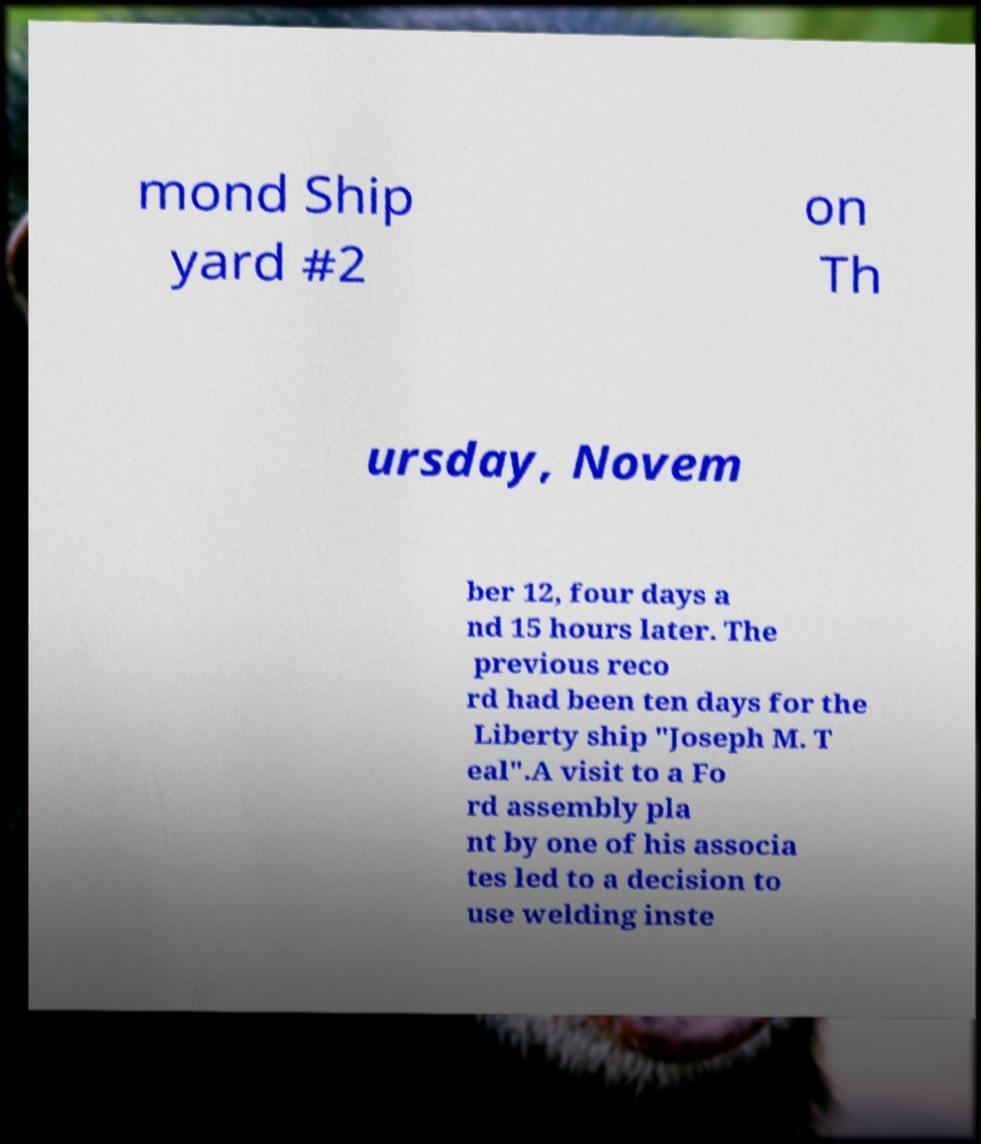Could you extract and type out the text from this image? mond Ship yard #2 on Th ursday, Novem ber 12, four days a nd 15 hours later. The previous reco rd had been ten days for the Liberty ship "Joseph M. T eal".A visit to a Fo rd assembly pla nt by one of his associa tes led to a decision to use welding inste 